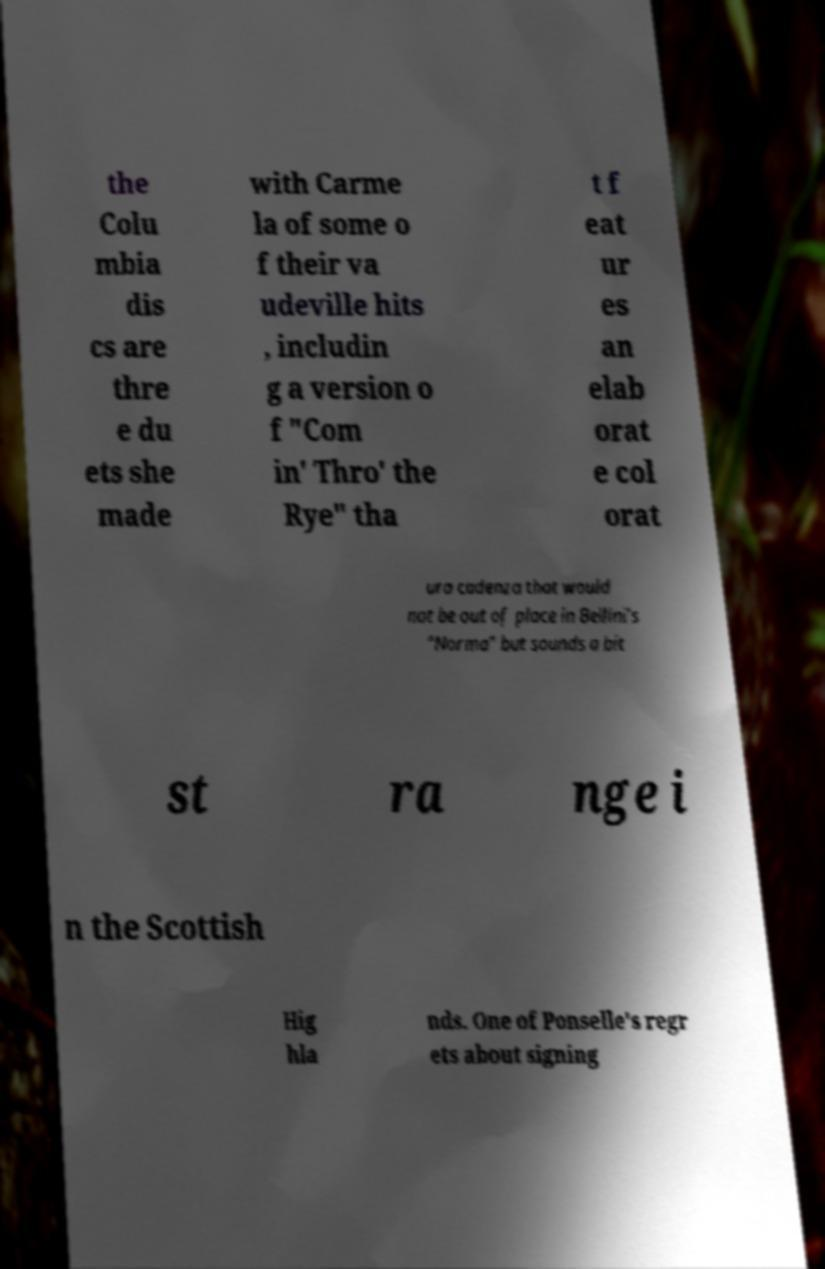Please read and relay the text visible in this image. What does it say? the Colu mbia dis cs are thre e du ets she made with Carme la of some o f their va udeville hits , includin g a version o f "Com in' Thro' the Rye" tha t f eat ur es an elab orat e col orat ura cadenza that would not be out of place in Bellini's "Norma" but sounds a bit st ra nge i n the Scottish Hig hla nds. One of Ponselle's regr ets about signing 